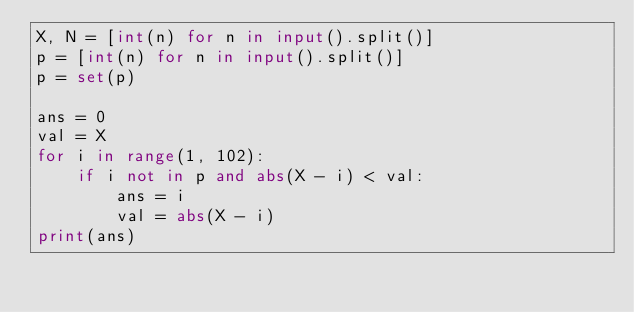Convert code to text. <code><loc_0><loc_0><loc_500><loc_500><_Python_>X, N = [int(n) for n in input().split()]
p = [int(n) for n in input().split()]
p = set(p)

ans = 0
val = X
for i in range(1, 102):
    if i not in p and abs(X - i) < val:
        ans = i
        val = abs(X - i)
print(ans)


</code> 